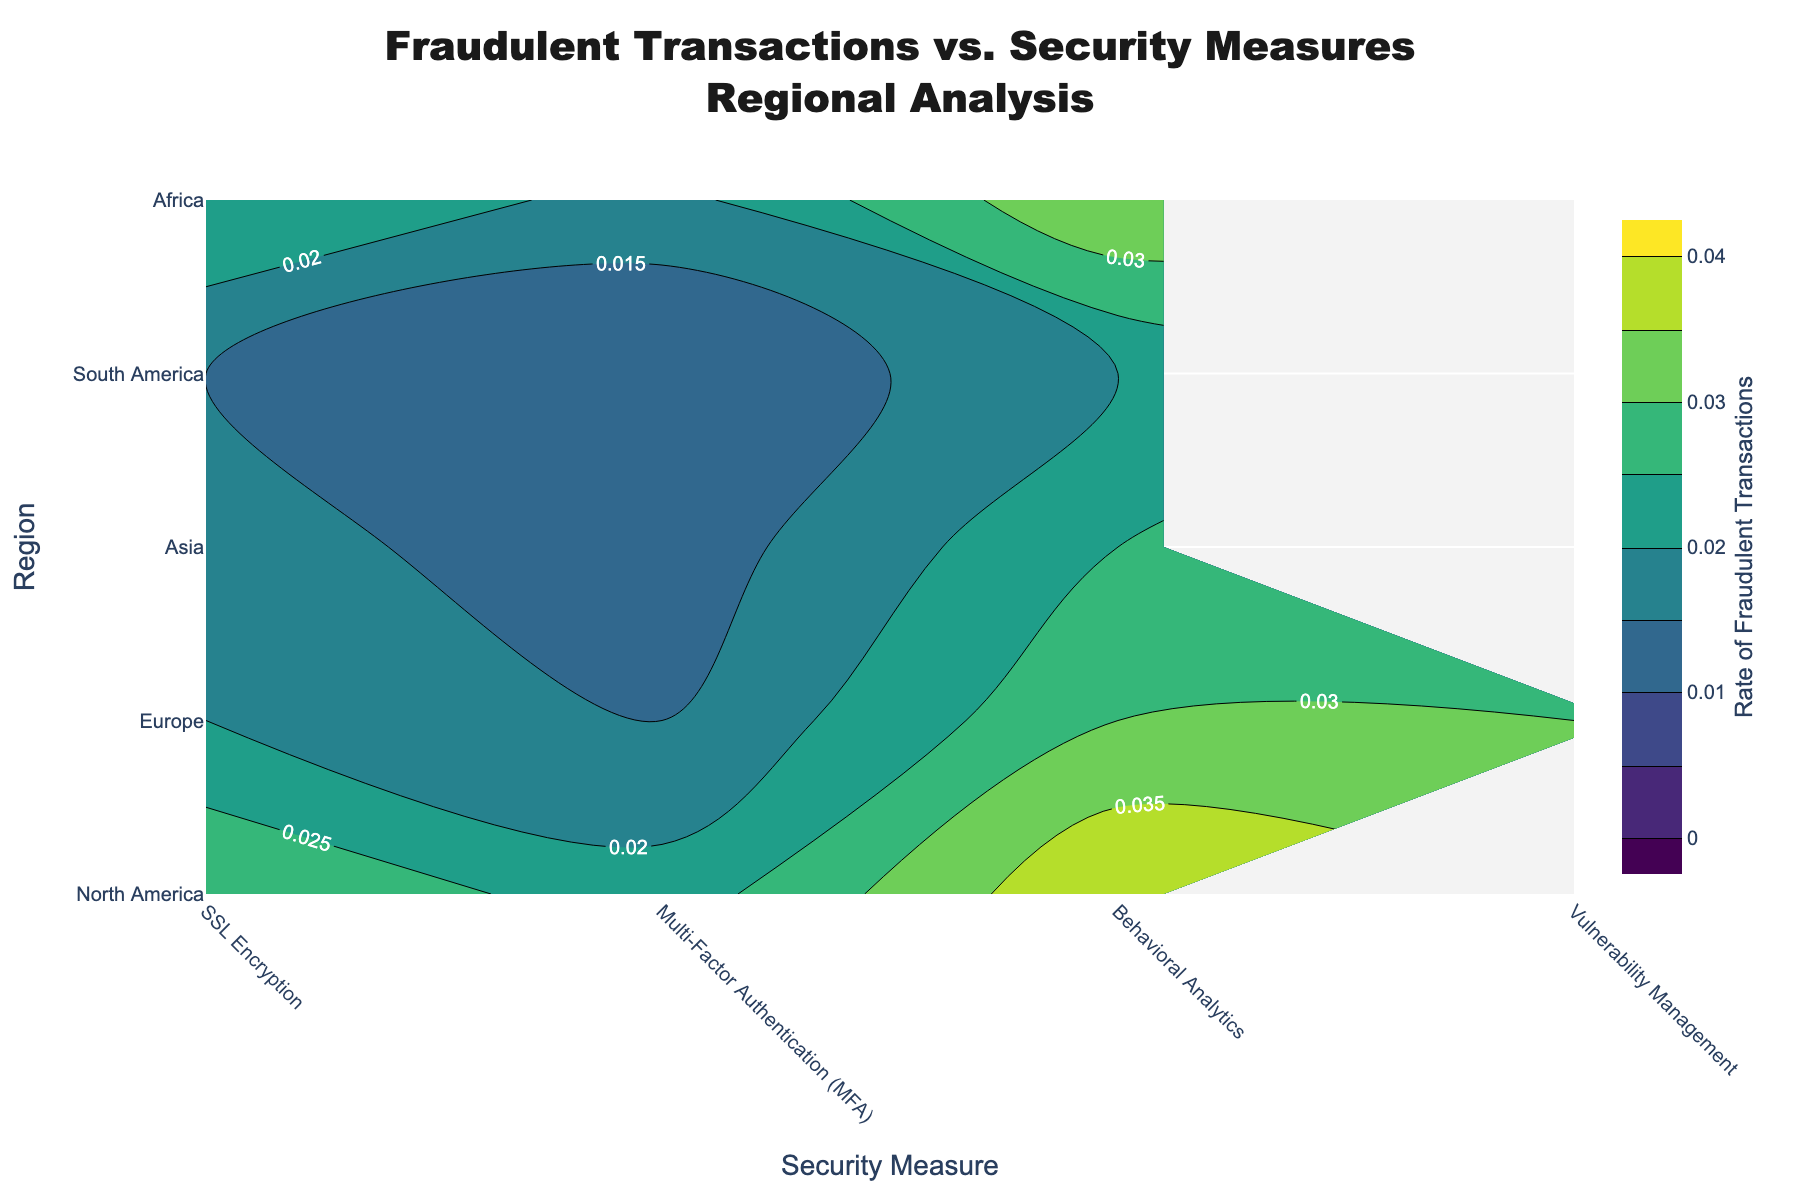What is the title of this figure? The title is clearly displayed at the top of the figure. It reads "Fraudulent Transactions vs. Security Measures<br>Regional Analysis".
Answer: Fraudulent Transactions vs. Security Measures<br>Regional Analysis Which region has the highest rate of fraudulent transactions for SSL Encryption? By examining the contour plot and focusing on the y-axis labels and the corresponding SSL Encryption column, we identify the rates. The highest is in Africa with a rate of 0.04.
Answer: Africa How does the rate of fraudulent transactions in Africa for Multi-Factor Authentication (MFA) compare to that in Europe? Locate the rate for Africa at the intersection of Africa on the y-axis and Multi-Factor Authentication on the x-axis, which is 0.022. Compare it to Europe's rate of 0.012. Africa's rate is higher.
Answer: Africa has a higher rate What is the average rate of fraudulent transactions for Behavioral Analytics across all regions? The rates for Behavioral Analytics across all regions are 0.015 (North America), 0.017 (Europe), 0.02 (Asia), 0.025 (South America), and 0.03 (Africa). Sum these rates and divide by the number of regions: (0.015 + 0.017 + 0.02 + 0.025 + 0.03) / 5 = 0.0214.
Answer: 0.0214 Which security measure has the lowest rate of fraudulent transactions in North America? Locate the rates for each security measure within North America on the contour plot. The rates are 0.02 for SSL Encryption, 0.01 for Multi-Factor Authentication, and 0.015 for Behavioral Analytics. The lowest rate is 0.01, corresponding to Multi-Factor Authentication.
Answer: Multi-Factor Authentication Does Asia have a higher rate of fraudulent transactions for SSL Encryption than South America? Compare the rates for SSL Encryption in Asia and South America by finding the corresponding values on the contour plot. Asia shows a rate of 0.03, while South America shows a rate of 0.035. Asia has a lower rate.
Answer: No What is the difference in the rate of fraudulent transactions between SSL Encryption and Behavioral Analytics in Europe? Identify the rates in Europe for SSL Encryption and Behavioral Analytics. SSL Encryption is 0.025, and Behavioral Analytics is 0.017. Calculate the difference: 0.025 - 0.017 = 0.008.
Answer: 0.008 Which region shows the smallest variation in the rate of fraudulent transactions among all security measures? To find the smallest variation, determine the range (maximum rate - minimum rate) for each region. North America: 0.01 (MFA) to 0.02 (SSL) -> 0.01, Europe: 0.012 (MFA) to 0.025 (SSL) -> 0.013, Asia: 0.015 (MFA) to 0.03 (SSL) -> 0.015, South America: 0.018 (MFA) to 0.035 (SSL) -> 0.017, Africa: 0.022 (MFA) to 0.04 (SSL) -> 0.018. The smallest variation is in North America with 0.01.
Answer: North America 